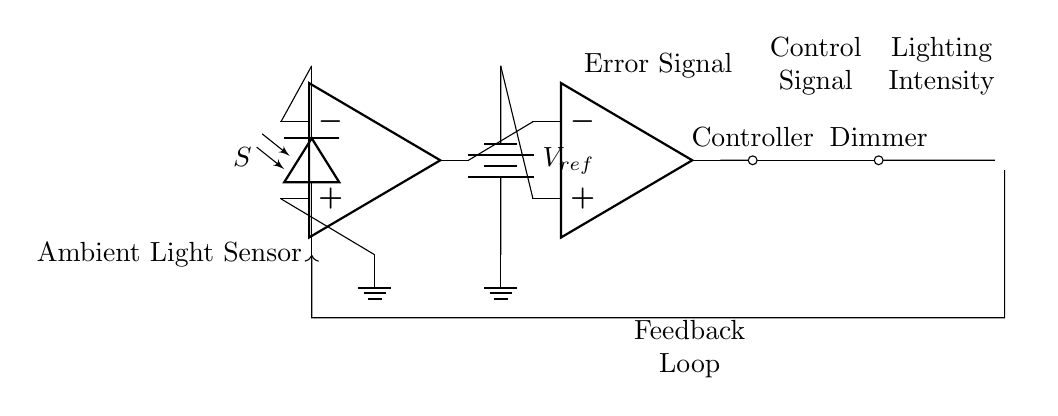What type of sensor is used in this control system? The system uses an ambient light sensor, which is indicated by the label "Ambient Light Sensor" and the photodiode symbol in the circuit.
Answer: Ambient light sensor What is the purpose of the amplifier in the circuit? The amplifier is used to boost the signal from the ambient light sensor, allowing the circuit to process a clearer and stronger signal. This is indicated by its placement between the sensor and the comparator.
Answer: To boost the signal Which component acts as the controller in this circuit? The controller is represented by the circle labeled "Controller" in the diagram, which follows the comparator.
Answer: Controller What determines the lighting intensity in this circuit? The lighting intensity is determined by the actuator (Dimmer), which receives control signals from the controller, as indicated by the arrows connecting these components.
Answer: Dimmer How does feedback in the circuit work? Feedback is indicated by the arrow looping from the stadium lights back to the ambient light sensor. This allows the system to adjust the lighting based on the actual intensity compared to the ambient light level.
Answer: Adjusts lighting based on intensity What type of control system is depicted in the diagram? The control system is a closed-loop control system, as evidenced by the feedback loop that connects the output (stadium lights) back to the input (ambient light sensor).
Answer: Closed-loop What is connected to the positive input of the comparator? The positive input of the comparator is connected to the reference voltage indicated by the battery symbol labeled "V_ref," which serves as a threshold for comparison.
Answer: Reference voltage 